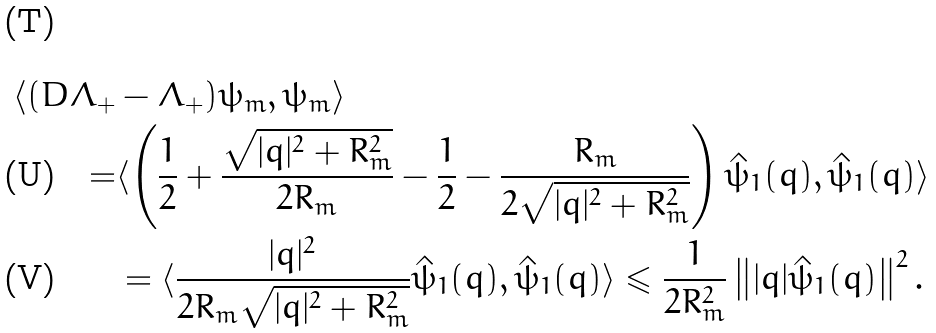Convert formula to latex. <formula><loc_0><loc_0><loc_500><loc_500>\langle ( D \Lambda _ { + } & - \Lambda _ { + } ) \psi _ { m } , \psi _ { m } \rangle \\ = & \langle \left ( \frac { 1 } { 2 } + \frac { \sqrt { | q | ^ { 2 } + R _ { m } ^ { 2 } } } { 2 R _ { m } } - \frac { 1 } { 2 } - \frac { R _ { m } } { 2 \sqrt { | q | ^ { 2 } + R _ { m } ^ { 2 } } } \right ) \hat { \psi } _ { 1 } ( q ) , \hat { \psi } _ { 1 } ( q ) \rangle \\ & = \langle \frac { | q | ^ { 2 } } { 2 R _ { m } \sqrt { | q | ^ { 2 } + R _ { m } ^ { 2 } } } \hat { \psi } _ { 1 } ( q ) , \hat { \psi } _ { 1 } ( q ) \rangle \leqslant \frac { 1 } { 2 R _ { m } ^ { 2 } } \left \| | q | \hat { \psi } _ { 1 } ( q ) \right \| ^ { 2 } .</formula> 